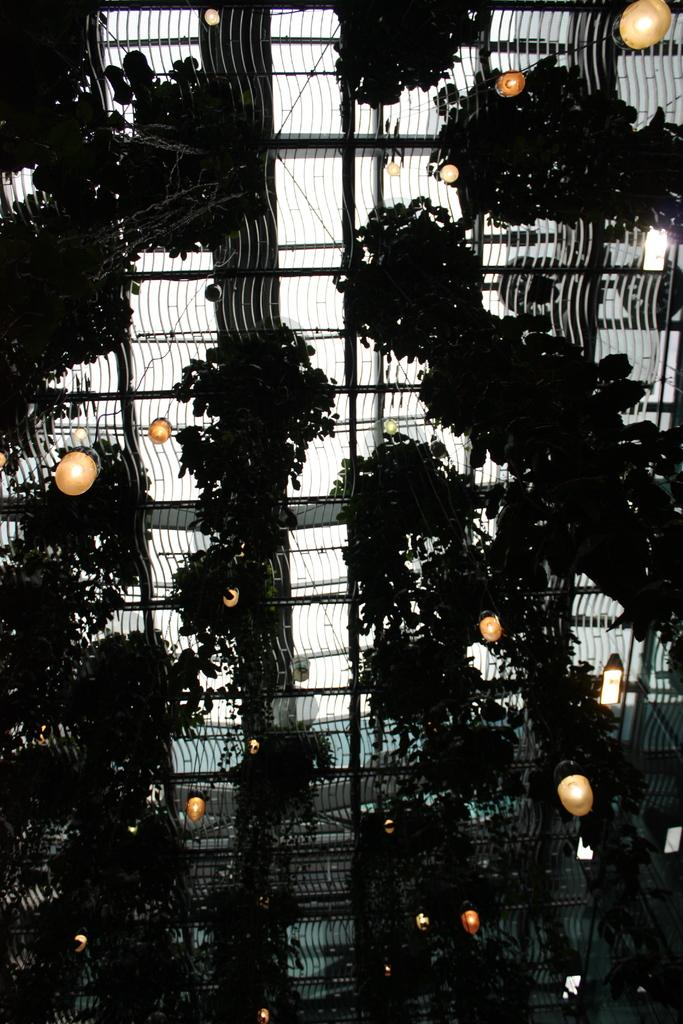What type of living organisms can be seen in the image? Plants can be seen in the image. What is hanging from a net in the image? There are lights hanging from a net in the image. What is the color of the sky in the image? The sky appears to be white in color. What type of thought can be seen floating in the image? There is no thought present in the image; it only features plants, lights, and a white sky. What kind of cheese is visible in the image? There is no cheese present in the image. 